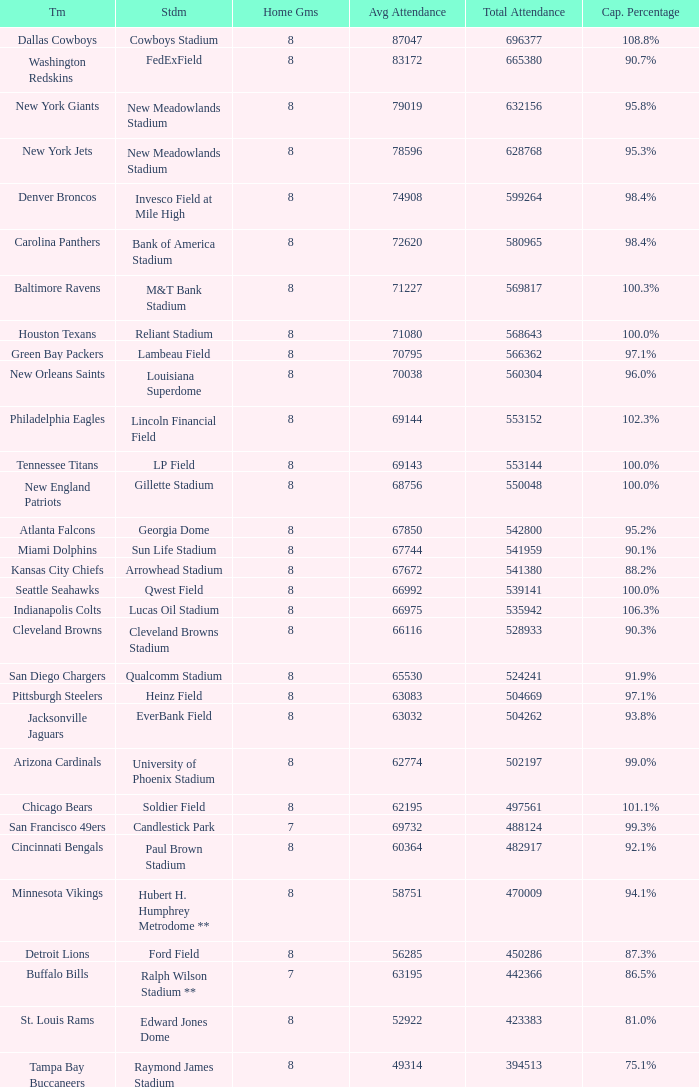What was the capacity percentage when attendance was 71080? 100.0%. I'm looking to parse the entire table for insights. Could you assist me with that? {'header': ['Tm', 'Stdm', 'Home Gms', 'Avg Attendance', 'Total Attendance', 'Cap. Percentage'], 'rows': [['Dallas Cowboys', 'Cowboys Stadium', '8', '87047', '696377', '108.8%'], ['Washington Redskins', 'FedExField', '8', '83172', '665380', '90.7%'], ['New York Giants', 'New Meadowlands Stadium', '8', '79019', '632156', '95.8%'], ['New York Jets', 'New Meadowlands Stadium', '8', '78596', '628768', '95.3%'], ['Denver Broncos', 'Invesco Field at Mile High', '8', '74908', '599264', '98.4%'], ['Carolina Panthers', 'Bank of America Stadium', '8', '72620', '580965', '98.4%'], ['Baltimore Ravens', 'M&T Bank Stadium', '8', '71227', '569817', '100.3%'], ['Houston Texans', 'Reliant Stadium', '8', '71080', '568643', '100.0%'], ['Green Bay Packers', 'Lambeau Field', '8', '70795', '566362', '97.1%'], ['New Orleans Saints', 'Louisiana Superdome', '8', '70038', '560304', '96.0%'], ['Philadelphia Eagles', 'Lincoln Financial Field', '8', '69144', '553152', '102.3%'], ['Tennessee Titans', 'LP Field', '8', '69143', '553144', '100.0%'], ['New England Patriots', 'Gillette Stadium', '8', '68756', '550048', '100.0%'], ['Atlanta Falcons', 'Georgia Dome', '8', '67850', '542800', '95.2%'], ['Miami Dolphins', 'Sun Life Stadium', '8', '67744', '541959', '90.1%'], ['Kansas City Chiefs', 'Arrowhead Stadium', '8', '67672', '541380', '88.2%'], ['Seattle Seahawks', 'Qwest Field', '8', '66992', '539141', '100.0%'], ['Indianapolis Colts', 'Lucas Oil Stadium', '8', '66975', '535942', '106.3%'], ['Cleveland Browns', 'Cleveland Browns Stadium', '8', '66116', '528933', '90.3%'], ['San Diego Chargers', 'Qualcomm Stadium', '8', '65530', '524241', '91.9%'], ['Pittsburgh Steelers', 'Heinz Field', '8', '63083', '504669', '97.1%'], ['Jacksonville Jaguars', 'EverBank Field', '8', '63032', '504262', '93.8%'], ['Arizona Cardinals', 'University of Phoenix Stadium', '8', '62774', '502197', '99.0%'], ['Chicago Bears', 'Soldier Field', '8', '62195', '497561', '101.1%'], ['San Francisco 49ers', 'Candlestick Park', '7', '69732', '488124', '99.3%'], ['Cincinnati Bengals', 'Paul Brown Stadium', '8', '60364', '482917', '92.1%'], ['Minnesota Vikings', 'Hubert H. Humphrey Metrodome **', '8', '58751', '470009', '94.1%'], ['Detroit Lions', 'Ford Field', '8', '56285', '450286', '87.3%'], ['Buffalo Bills', 'Ralph Wilson Stadium **', '7', '63195', '442366', '86.5%'], ['St. Louis Rams', 'Edward Jones Dome', '8', '52922', '423383', '81.0%'], ['Tampa Bay Buccaneers', 'Raymond James Stadium', '8', '49314', '394513', '75.1%']]} 